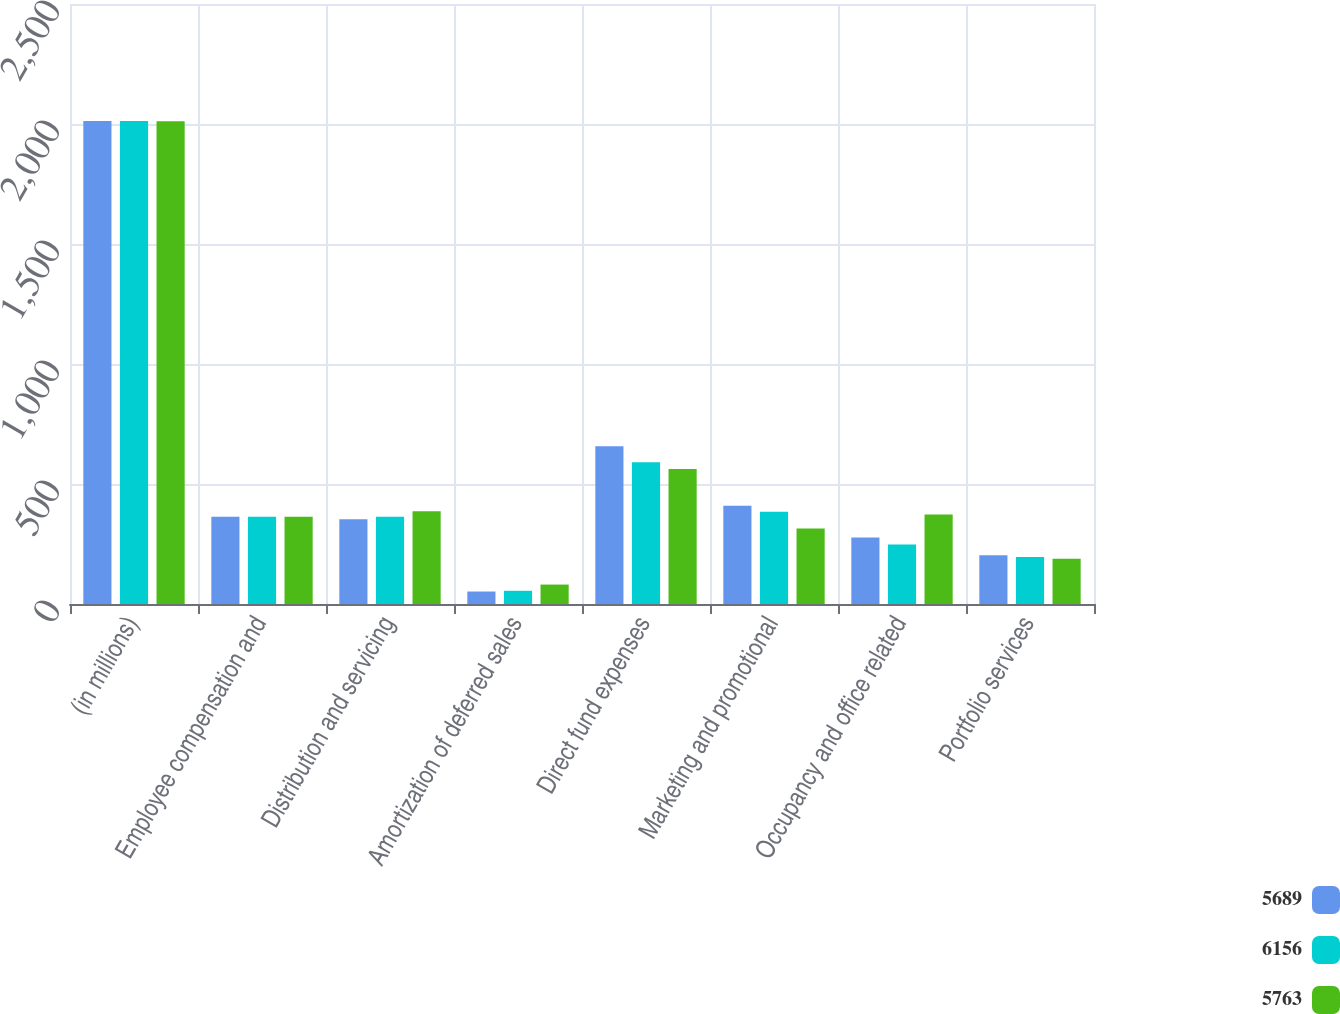Convert chart to OTSL. <chart><loc_0><loc_0><loc_500><loc_500><stacked_bar_chart><ecel><fcel>(in millions)<fcel>Employee compensation and<fcel>Distribution and servicing<fcel>Amortization of deferred sales<fcel>Direct fund expenses<fcel>Marketing and promotional<fcel>Occupancy and office related<fcel>Portfolio services<nl><fcel>5689<fcel>2013<fcel>364<fcel>353<fcel>52<fcel>657<fcel>409<fcel>277<fcel>203<nl><fcel>6156<fcel>2012<fcel>364<fcel>364<fcel>55<fcel>591<fcel>384<fcel>248<fcel>196<nl><fcel>5763<fcel>2011<fcel>364<fcel>386<fcel>81<fcel>563<fcel>315<fcel>373<fcel>189<nl></chart> 